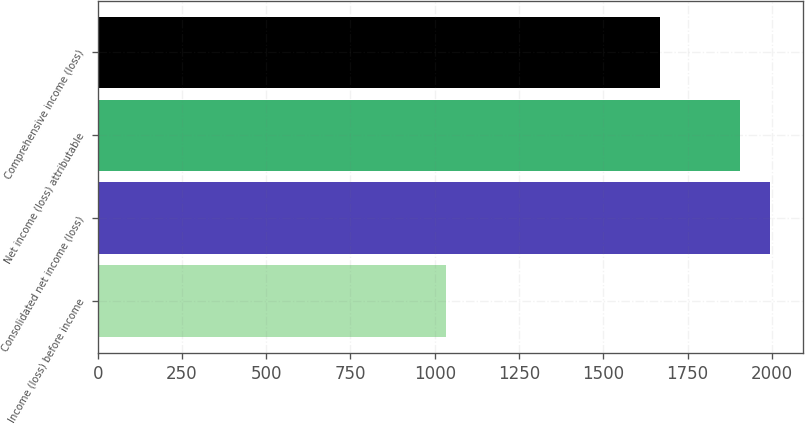Convert chart to OTSL. <chart><loc_0><loc_0><loc_500><loc_500><bar_chart><fcel>Income (loss) before income<fcel>Consolidated net income (loss)<fcel>Net income (loss) attributable<fcel>Comprehensive income (loss)<nl><fcel>1034.8<fcel>1993.55<fcel>1906.1<fcel>1668.1<nl></chart> 